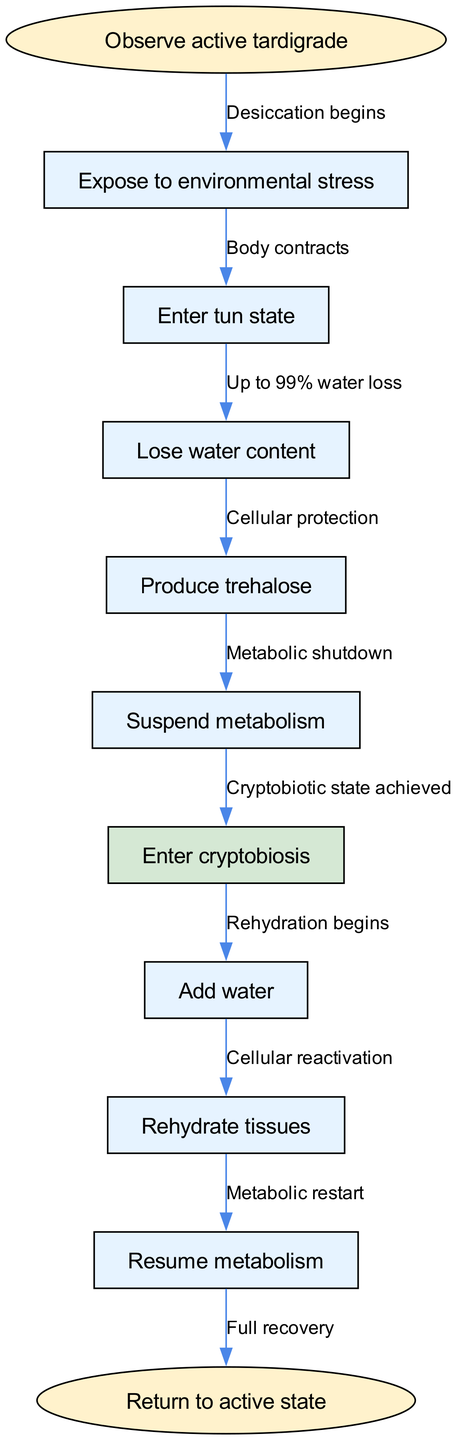What is the starting point of the process? The diagram indicates that the process begins with the observation of an active tardigrade. This is represented by the start node labeled 'Observe active tardigrade'.
Answer: Observe active tardigrade How many nodes are in the diagram? By counting the nodes in the diagram, including the start node and the subsequent process stages, we find there are a total of 10 nodes.
Answer: 10 What happens after 'Suspend metabolism'? From the flow of the diagram, after 'Suspend metabolism', the next process that occurs is 'Enter cryptobiosis'. This indicates that suspension leads directly to this critical state of dormancy.
Answer: Enter cryptobiosis What is produced during the loss of water content? The diagram illustrates that when a tardigrade loses water content, it simultaneously produces trehalose, which acts as a protective sugar during the desiccation process.
Answer: Produce trehalose How is the transition to active state marked? The transition back to an active state is marked by the node 'Return to active state', which follows the rehydration process, demonstrating the final step in the revival of the tardigrade.
Answer: Return to active state What are the consequences of entering the tun state? Entering the tun state leads to body contraction, which is a direct result of the environmental stress exposure, and this contraction is critical for the tardigrade's cryptobiotic survival.
Answer: Body contracts What major change occurs during 'Enter cryptobiosis'? When the tardigrade achieves 'Enter cryptobiosis', it signifies that the cryptobiotic state is reached, resulting in significant metabolic shutdown and desiccation. This step represents a survival mechanism.
Answer: Cryptobiotic state achieved Which node follows 'Rehydrate tissues'? According to the flow of the diagram, 'Resume metabolism' is the next node that follows 'Rehydrate tissues', indicating the sequential process of reactivation after rehydration.
Answer: Resume metabolism What is the percentage of water loss during the process? The diagram states that the water loss can be up to 99%, which underscores the extreme resilience of tardigrades in surviving desiccation.
Answer: Up to 99% water loss 